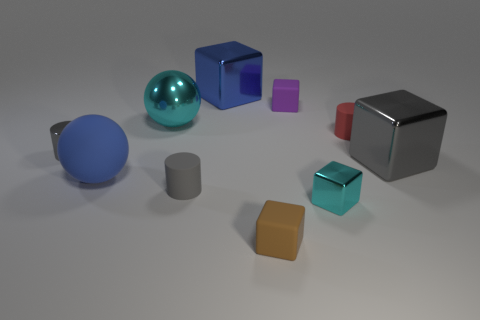Subtract 1 cubes. How many cubes are left? 4 Subtract all brown cubes. How many cubes are left? 4 Subtract all big blue blocks. How many blocks are left? 4 Subtract all blue cubes. Subtract all cyan cylinders. How many cubes are left? 4 Subtract all spheres. How many objects are left? 8 Subtract 0 red cubes. How many objects are left? 10 Subtract all tiny red metal blocks. Subtract all tiny cylinders. How many objects are left? 7 Add 1 red matte cylinders. How many red matte cylinders are left? 2 Add 1 brown matte spheres. How many brown matte spheres exist? 1 